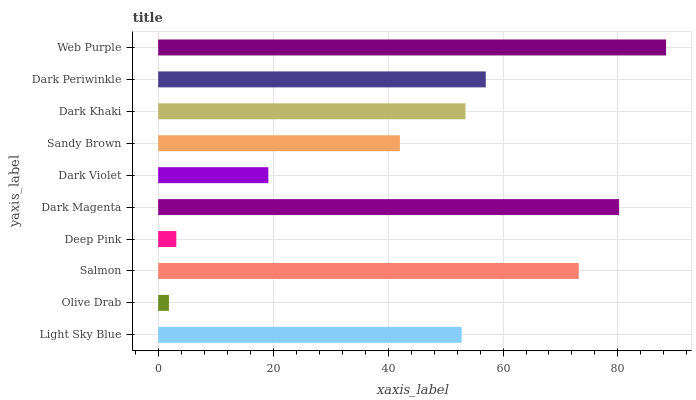Is Olive Drab the minimum?
Answer yes or no. Yes. Is Web Purple the maximum?
Answer yes or no. Yes. Is Salmon the minimum?
Answer yes or no. No. Is Salmon the maximum?
Answer yes or no. No. Is Salmon greater than Olive Drab?
Answer yes or no. Yes. Is Olive Drab less than Salmon?
Answer yes or no. Yes. Is Olive Drab greater than Salmon?
Answer yes or no. No. Is Salmon less than Olive Drab?
Answer yes or no. No. Is Dark Khaki the high median?
Answer yes or no. Yes. Is Light Sky Blue the low median?
Answer yes or no. Yes. Is Dark Magenta the high median?
Answer yes or no. No. Is Olive Drab the low median?
Answer yes or no. No. 